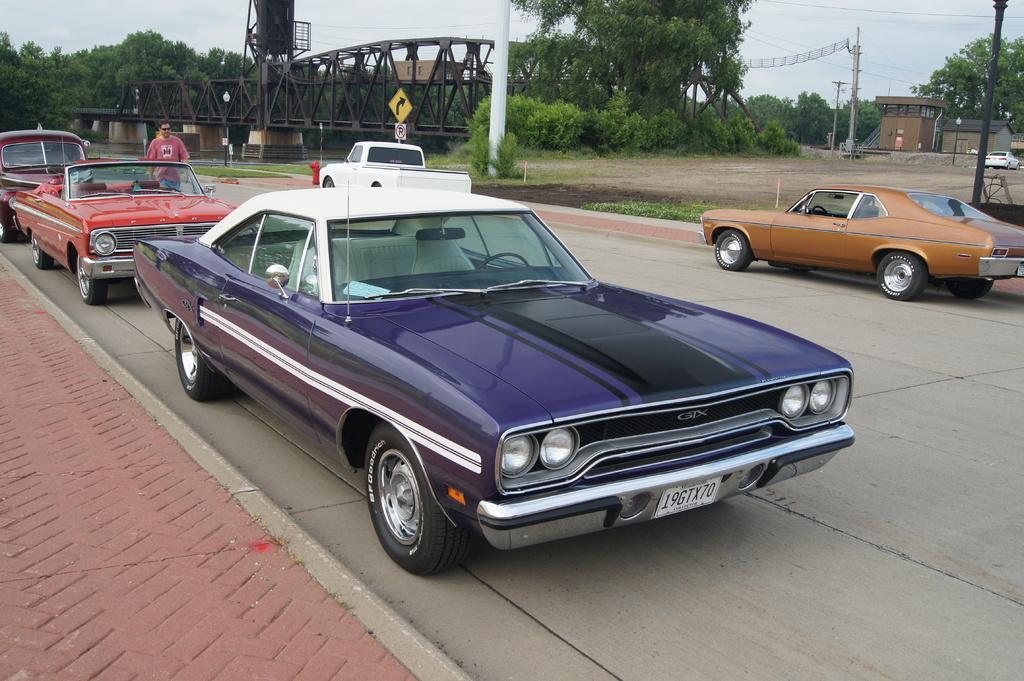Could you give a brief overview of what you see in this image? In this image, we can see some cars on the road. There is a bridge in between trees. There are poles in the top right of the image. There is a person wearing clothes in the top left of the image. 